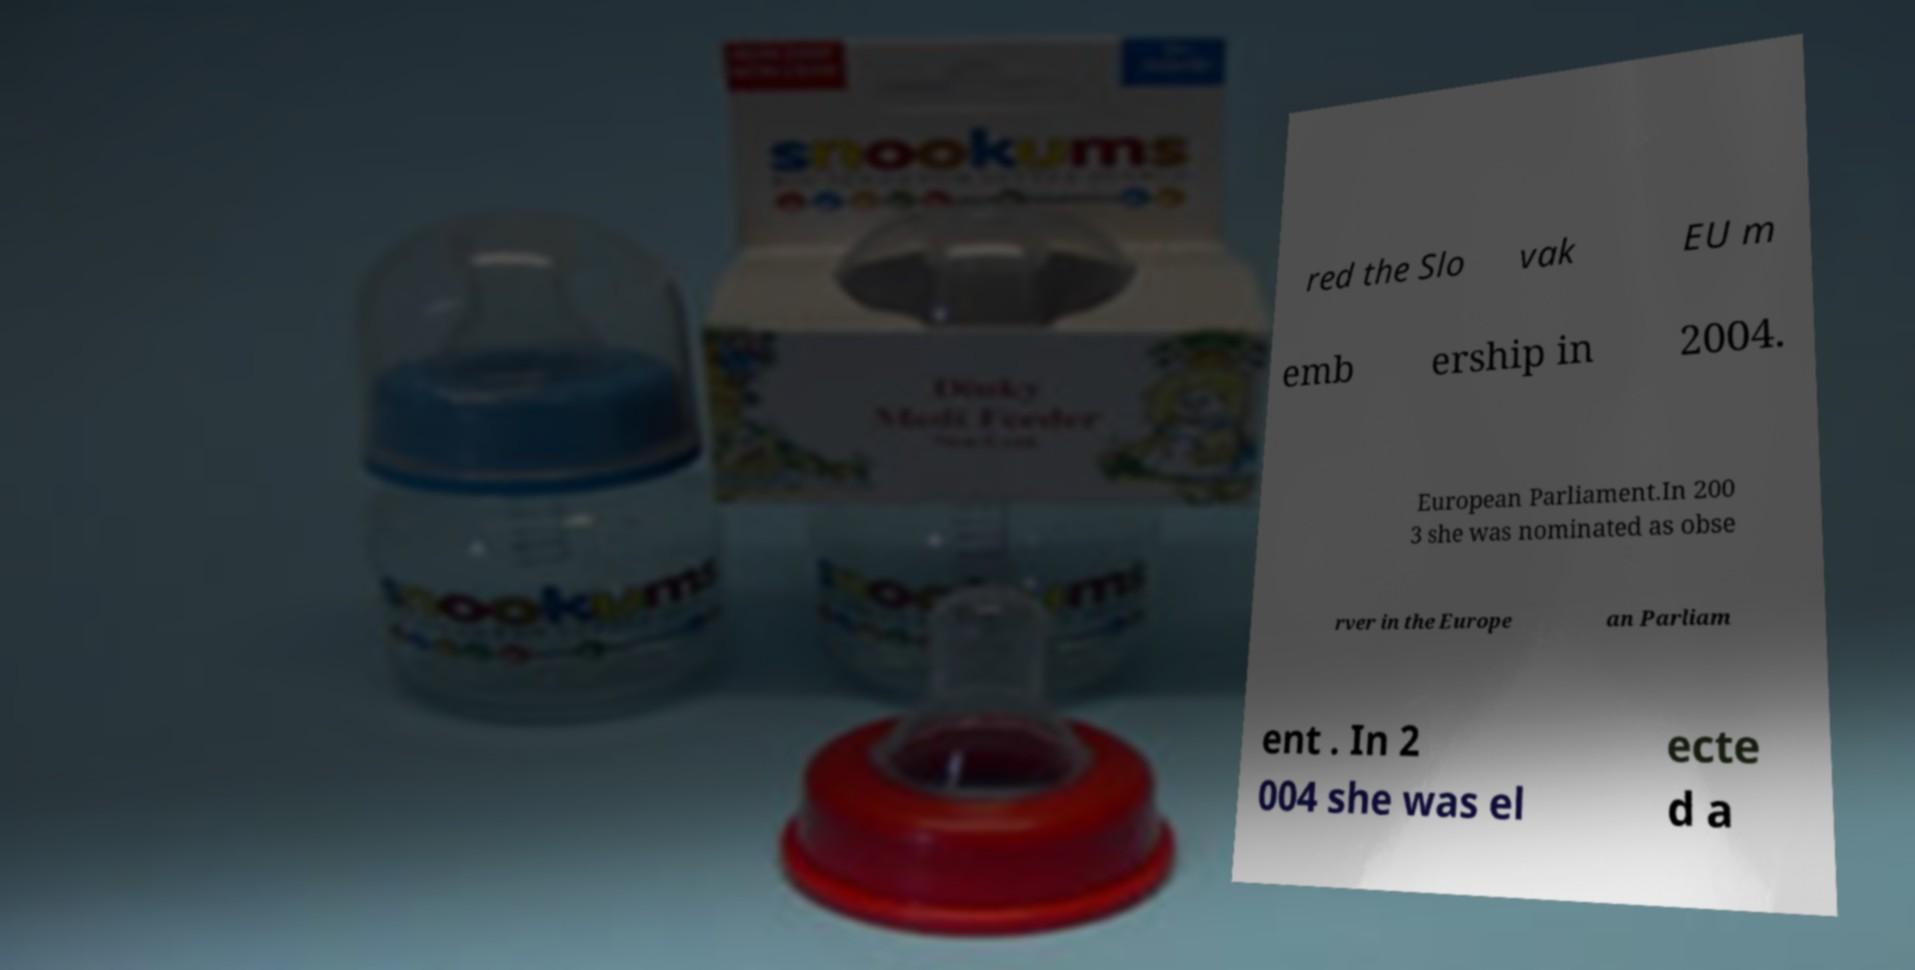I need the written content from this picture converted into text. Can you do that? red the Slo vak EU m emb ership in 2004. European Parliament.In 200 3 she was nominated as obse rver in the Europe an Parliam ent . In 2 004 she was el ecte d a 